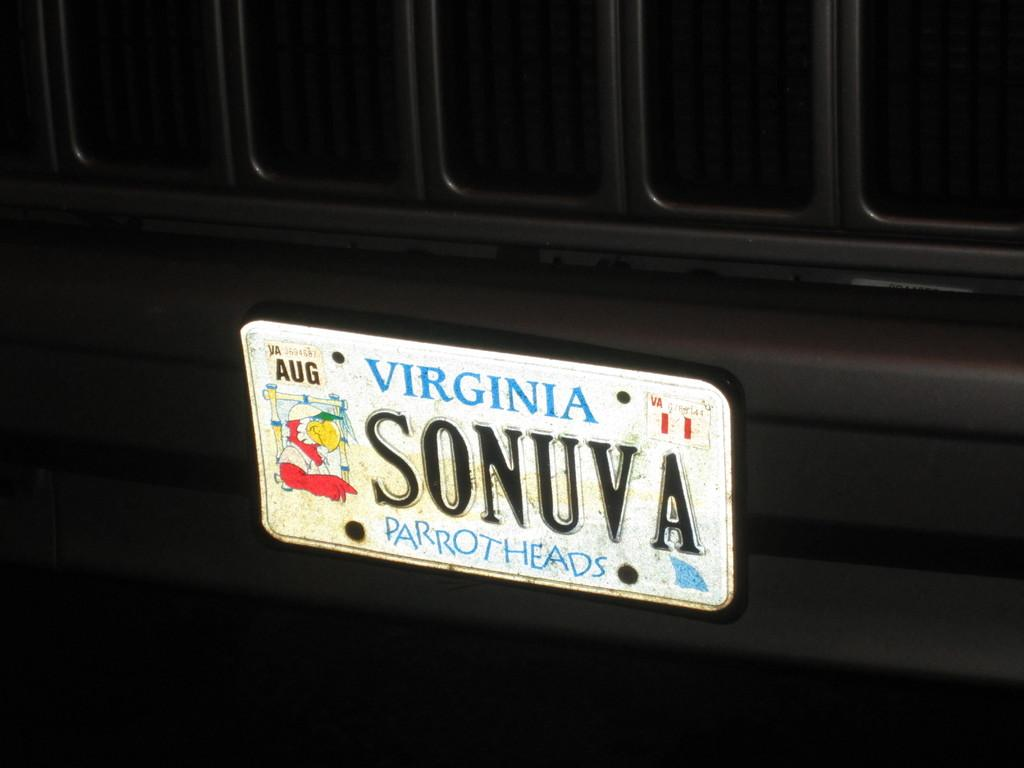Provide a one-sentence caption for the provided image. License plate from Virginia that says parrot heads. 